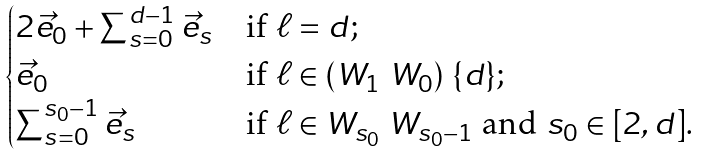Convert formula to latex. <formula><loc_0><loc_0><loc_500><loc_500>\begin{cases} 2 \vec { e } _ { 0 } + \sum _ { s = 0 } ^ { d - 1 } \vec { e } _ { s } & \text {if } \ell = d ; \\ \vec { e } _ { 0 } & \text {if } \ell \in ( W _ { 1 } \ W _ { 0 } ) \ \{ d \} ; \\ \sum _ { s = 0 } ^ { s _ { 0 } - 1 } \vec { e } _ { s } & \text {if } \ell \in W _ { s _ { 0 } } \ W _ { s _ { 0 } - 1 } \text { and } s _ { 0 } \in [ 2 , d ] . \end{cases}</formula> 